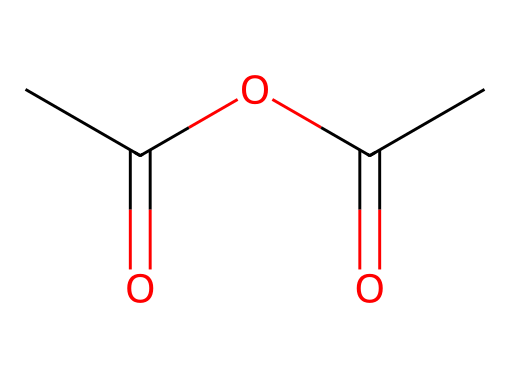how many carbon atoms are in acetic anhydride? The SMILES representation CC(=O)OC(=O)C shows four carbon atoms. Each 'C' represents a carbon atom, and there are four instances of 'C' in the SMILES.
Answer: four what functional group is present in acetic anhydride? Looking at the structure, the portions with C(=O) are carbonyl groups. Since they are linked by an oxygen, the functional group present is an anhydride.
Answer: anhydride how many oxygen atoms are present in acetic anhydride? The SMILES representation contains two occurrences of 'O' in the segment OC(=O), indicating there are two oxygen atoms in the structure.
Answer: two what type of bonds connect the carbon atoms in acetic anhydride? In the acetic anhydride structure, the carbon atoms are connected by single and double bonds. The connection to the carbonyl is a double bond (C=O), while C–C connections are single.
Answer: single and double bonds what is the molecular formula of acetic anhydride? To derive the molecular formula, count the atoms depicted in the SMILES: 4 carbon (C), 6 hydrogen (H), and 2 oxygen (O). The resulting molecular formula is C4H6O3.
Answer: C4H6O3 what property makes acetic anhydride useful as a chemical reagent? Acetic anhydride is a strong acetylation agent due to its ability to readily react with nucleophiles, making it efficient for various chemical reactions, especially in the synthesis of other compounds.
Answer: acetylation agent how does acetic anhydride relate to ester formation? Acetic anhydride acts as a source of acyl groups, facilitating the reaction with alcohols to form esters, which is a hallmark of its use in organic synthesis. This is characterized by nucleophilic attack by the alcohol on the acyl group.
Answer: forms esters 